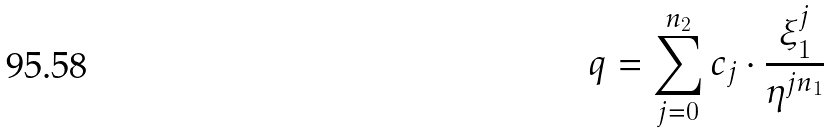Convert formula to latex. <formula><loc_0><loc_0><loc_500><loc_500>q = \sum _ { j = 0 } ^ { n _ { 2 } } c _ { j } \cdot \frac { \xi _ { 1 } ^ { j } } { \eta ^ { j n _ { 1 } } }</formula> 